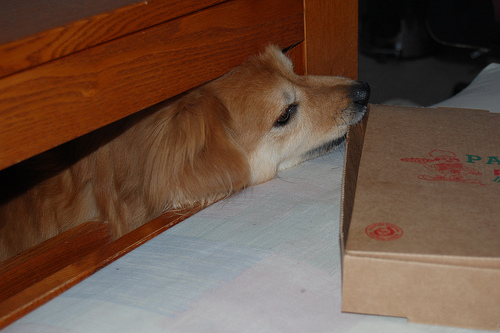<image>
Is there a dog on the bed? No. The dog is not positioned on the bed. They may be near each other, but the dog is not supported by or resting on top of the bed. Is the dog above the bed? No. The dog is not positioned above the bed. The vertical arrangement shows a different relationship. 